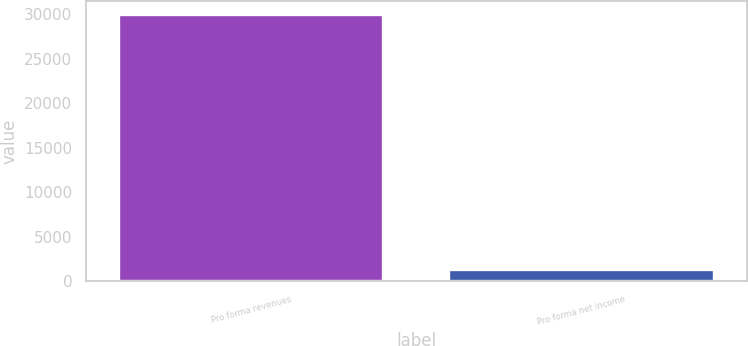Convert chart to OTSL. <chart><loc_0><loc_0><loc_500><loc_500><bar_chart><fcel>Pro forma revenues<fcel>Pro forma net income<nl><fcel>29925<fcel>1257<nl></chart> 